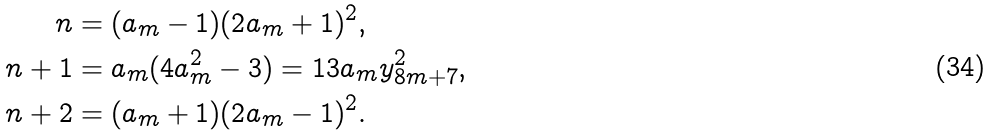Convert formula to latex. <formula><loc_0><loc_0><loc_500><loc_500>n & = ( a _ { m } - 1 ) ( 2 a _ { m } + 1 ) ^ { 2 } , \\ n + 1 & = a _ { m } ( 4 a _ { m } ^ { 2 } - 3 ) = 1 3 a _ { m } y _ { 8 m + 7 } ^ { 2 } , \\ n + 2 & = ( a _ { m } + 1 ) ( 2 a _ { m } - 1 ) ^ { 2 } . \\</formula> 